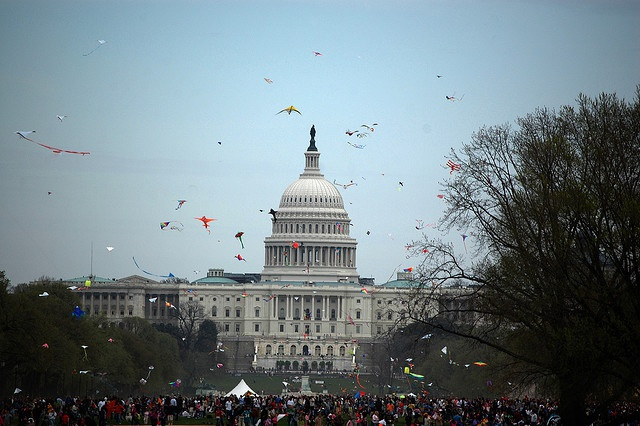Describe the objects in this image and their specific colors. I can see people in gray, black, and lightblue tones, kite in gray, black, lightblue, and darkgray tones, kite in gray, darkgray, and brown tones, people in gray, black, maroon, and brown tones, and people in gray and black tones in this image. 